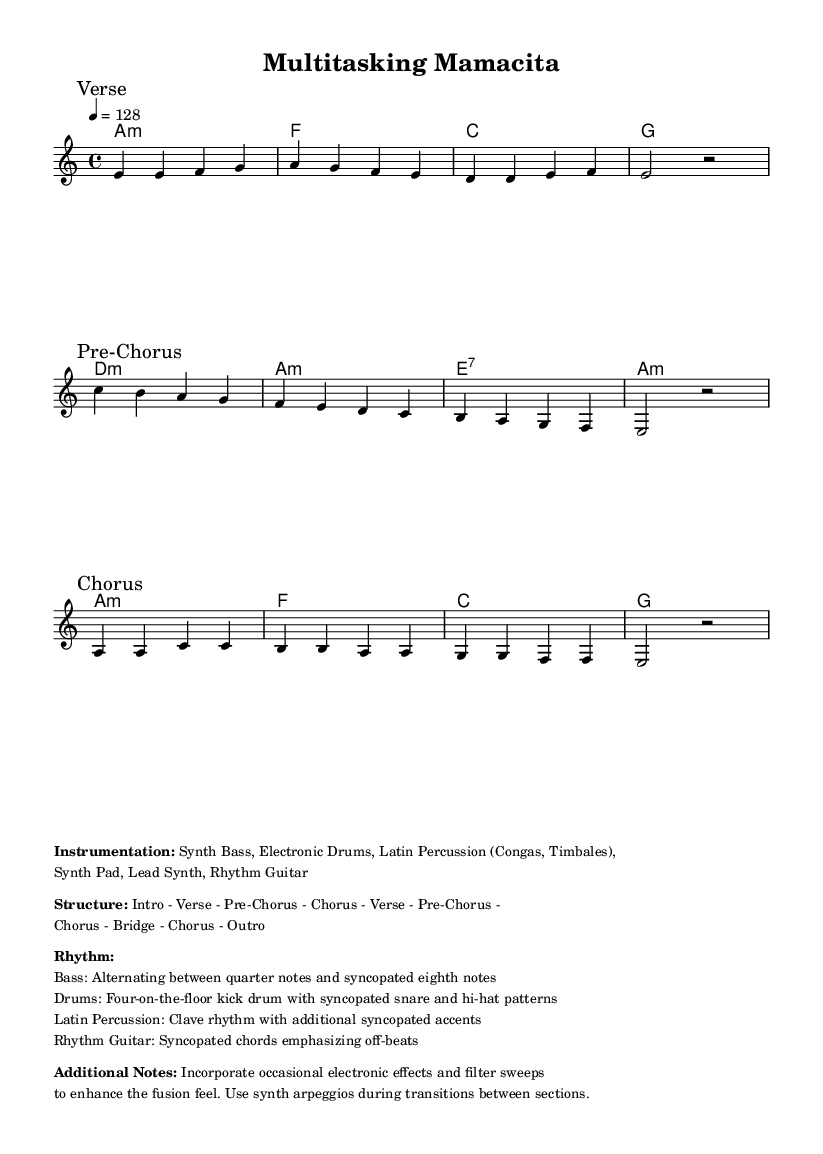What is the key signature of this music? The key signature is A minor, which has no sharps or flats. A minor is indicated at the beginning of the sheet music, confirming the key.
Answer: A minor What is the time signature of this music? The time signature is 4/4, which is commonly used in many styles of music, including Latin and electronic. It is indicated at the beginning of the piece, right after the key signature.
Answer: 4/4 What is the tempo marking indicated in this sheet music? The tempo marking is 128 beats per minute, specified at the start of the piece. This tempo is suitable for upbeat and danceable music, aligning with the Latin-electronic fusion genre.
Answer: 128 How many sections are there in the structure of the song? The structure includes nine sections as listed in the markup, starting from the intro to the outro. Counting each labeled section gives the total number of sections present.
Answer: Nine What style of percussion is featured in this music? The music features Latin percussion, including congas and timbales, as noted in the instrumentation list. This is a key characteristic of the Latin-electronic fusion style, adding vibrant rhythms to the piece.
Answer: Latin percussion What kind of rhythm does the bass follow in this composition? The bass follows a rhythm of alternating between quarter notes and syncopated eighth notes. This rhythmic variation is specified in the additional notes and is essential for creating a lively feel in the fusion music.
Answer: Alternating quarter notes and syncopated eighth notes 